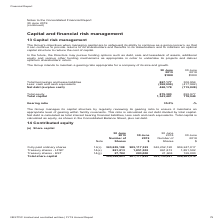According to Nextdc's financial document, How does the Group manages its capital structure ? by regularly reviewing its gearing ratio to ensure it maintains an appropriate level of gearing within facility covenants.. The document states: "The Group manages its capital structure by regularly reviewing its gearing ratio to ensure it maintains an appropriate level of gearing within facilit..." Also, What is the gearing ratio in 2019? According to the financial document, 35.0%. The relevant text states: "Gearing ratio 35.0% -%..." Also, How much was the total capital in 2018? According to the financial document, 778,949 (in thousands). The relevant text states: "al equity 875,303 893,977 Total capital 1,343,481 778,949..." Also, can you calculate: What was the percentage change in total capital between 2018 and 2019? To answer this question, I need to perform calculations using the financial data. The calculation is: (1,343,481 - 778,949) / 778,949 , which equals 72.47 (percentage). This is based on the information: "al equity 875,303 893,977 Total capital 1,343,481 778,949 Total equity 875,303 893,977 Total capital 1,343,481 778,949..." The key data points involved are: 1,343,481, 778,949. Also, can you calculate: What was the percentage of total equity among total capital in 2019? Based on the calculation: 875,303 / 1,343,481 , the result is 65.15 (percentage). This is based on the information: "Total equity 875,303 893,977 Total capital 1,343,481 778,949 Total equity 875,303 893,977 Total capital 1,343,481 778,949..." The key data points involved are: 1,343,481, 875,303. Also, can you calculate: What was the percentage change in total borrowings and lease between 2018 and 2019? To answer this question, I need to perform calculations using the financial data. The calculation is: (867,177 - 302,954) / 302,954 , which equals 186.24 (percentage). This is based on the information: "Total borrowings and lease liabilities 867,177 302,954 Less: cash and cash equivalents (398,999) (417,982) Net debt (surplus cash) 468,178 (115,028) Total borrowings and lease liabilities 867,177 302,..." The key data points involved are: 302,954, 867,177. 